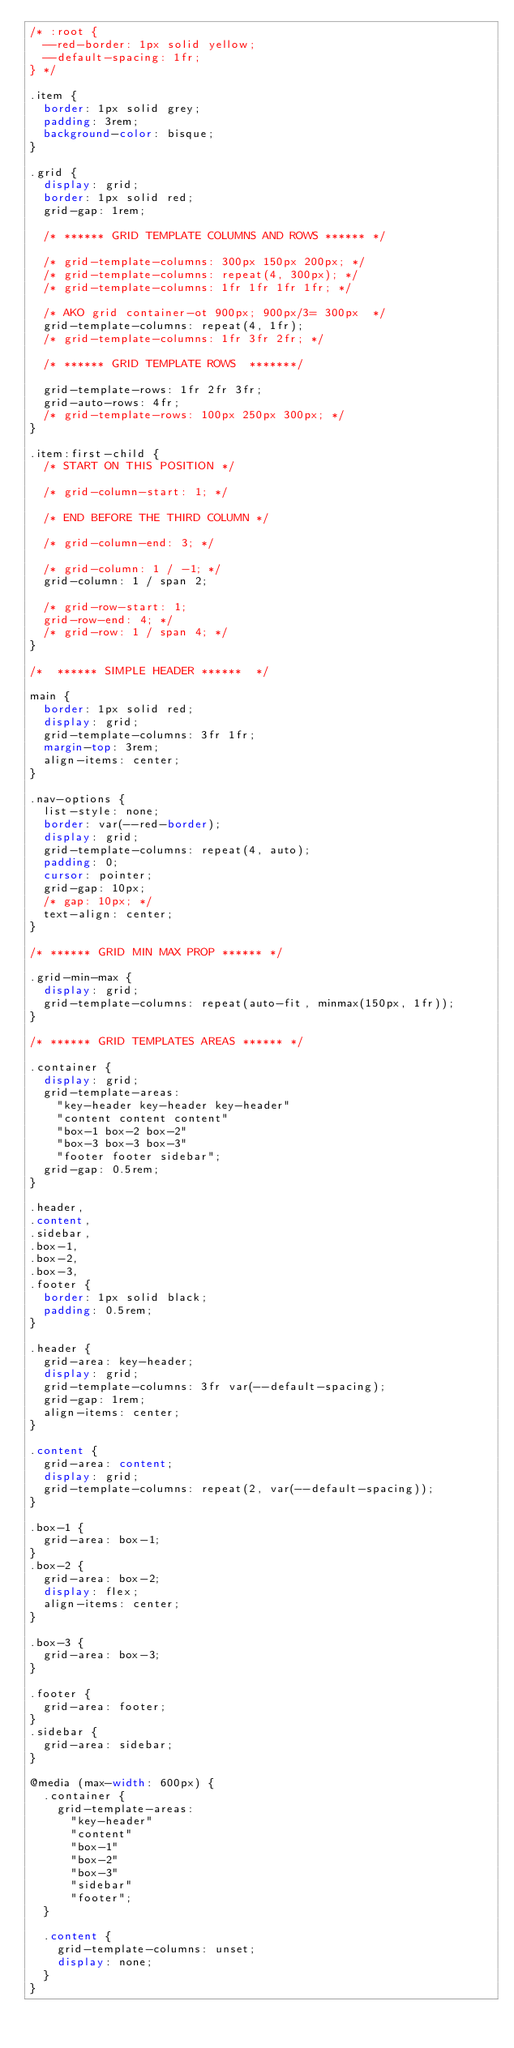Convert code to text. <code><loc_0><loc_0><loc_500><loc_500><_CSS_>/* :root {
  --red-border: 1px solid yellow;
  --default-spacing: 1fr;
} */

.item {
  border: 1px solid grey;
  padding: 3rem;
  background-color: bisque;
}

.grid {
  display: grid;
  border: 1px solid red;
  grid-gap: 1rem;

  /* ****** GRID TEMPLATE COLUMNS AND ROWS ****** */

  /* grid-template-columns: 300px 150px 200px; */
  /* grid-template-columns: repeat(4, 300px); */
  /* grid-template-columns: 1fr 1fr 1fr 1fr; */

  /* AKO grid container-ot 900px; 900px/3= 300px  */
  grid-template-columns: repeat(4, 1fr);
  /* grid-template-columns: 1fr 3fr 2fr; */

  /* ****** GRID TEMPLATE ROWS  *******/

  grid-template-rows: 1fr 2fr 3fr;
  grid-auto-rows: 4fr;
  /* grid-template-rows: 100px 250px 300px; */
}

.item:first-child {
  /* START ON THIS POSITION */

  /* grid-column-start: 1; */

  /* END BEFORE THE THIRD COLUMN */

  /* grid-column-end: 3; */

  /* grid-column: 1 / -1; */
  grid-column: 1 / span 2;

  /* grid-row-start: 1;
  grid-row-end: 4; */
  /* grid-row: 1 / span 4; */
}

/*  ****** SIMPLE HEADER ******  */

main {
  border: 1px solid red;
  display: grid;
  grid-template-columns: 3fr 1fr;
  margin-top: 3rem;
  align-items: center;
}

.nav-options {
  list-style: none;
  border: var(--red-border);
  display: grid;
  grid-template-columns: repeat(4, auto);
  padding: 0;
  cursor: pointer;
  grid-gap: 10px;
  /* gap: 10px; */
  text-align: center;
}

/* ****** GRID MIN MAX PROP ****** */

.grid-min-max {
  display: grid;
  grid-template-columns: repeat(auto-fit, minmax(150px, 1fr));
}

/* ****** GRID TEMPLATES AREAS ****** */

.container {
  display: grid;
  grid-template-areas:
    "key-header key-header key-header"
    "content content content"
    "box-1 box-2 box-2"
    "box-3 box-3 box-3"
    "footer footer sidebar";
  grid-gap: 0.5rem;
}

.header,
.content,
.sidebar,
.box-1,
.box-2,
.box-3,
.footer {
  border: 1px solid black;
  padding: 0.5rem;
}

.header {
  grid-area: key-header;
  display: grid;
  grid-template-columns: 3fr var(--default-spacing);
  grid-gap: 1rem;
  align-items: center;
}

.content {
  grid-area: content;
  display: grid;
  grid-template-columns: repeat(2, var(--default-spacing));
}

.box-1 {
  grid-area: box-1;
}
.box-2 {
  grid-area: box-2;
  display: flex;
  align-items: center;
}

.box-3 {
  grid-area: box-3;
}

.footer {
  grid-area: footer;
}
.sidebar {
  grid-area: sidebar;
}

@media (max-width: 600px) {
  .container {
    grid-template-areas:
      "key-header"
      "content"
      "box-1"
      "box-2"
      "box-3"
      "sidebar"
      "footer";
  }

  .content {
    grid-template-columns: unset;
    display: none;
  }
}
</code> 